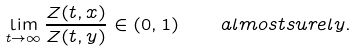Convert formula to latex. <formula><loc_0><loc_0><loc_500><loc_500>\lim _ { t \to \infty } \frac { Z ( t , x ) } { Z ( t , y ) } \in ( 0 , 1 ) \quad a l m o s t s u r e l y .</formula> 